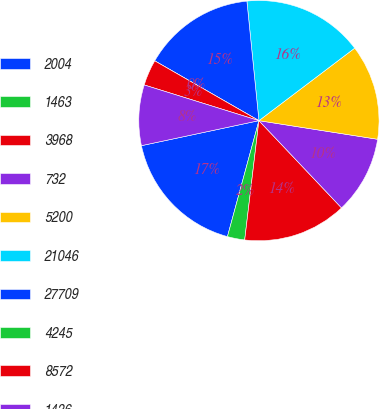Convert chart to OTSL. <chart><loc_0><loc_0><loc_500><loc_500><pie_chart><fcel>2004<fcel>1463<fcel>3968<fcel>732<fcel>5200<fcel>21046<fcel>27709<fcel>4245<fcel>8572<fcel>1436<nl><fcel>17.44%<fcel>2.33%<fcel>13.95%<fcel>10.46%<fcel>12.79%<fcel>16.28%<fcel>15.11%<fcel>0.0%<fcel>3.49%<fcel>8.14%<nl></chart> 